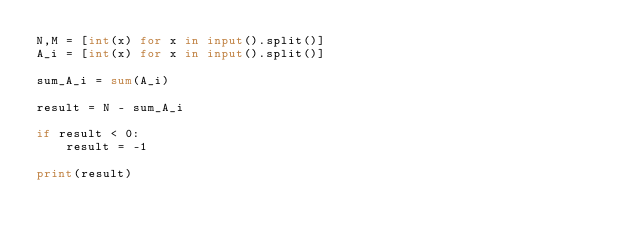<code> <loc_0><loc_0><loc_500><loc_500><_Python_>N,M = [int(x) for x in input().split()]
A_i = [int(x) for x in input().split()]

sum_A_i = sum(A_i)

result = N - sum_A_i

if result < 0:
    result = -1

print(result)</code> 